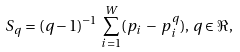Convert formula to latex. <formula><loc_0><loc_0><loc_500><loc_500>S _ { q } = ( q - 1 ) ^ { - 1 } \, \sum _ { i = 1 } ^ { W } ( p _ { i } \, - \, p _ { i } ^ { q } ) , \, q \in { \Re } ,</formula> 